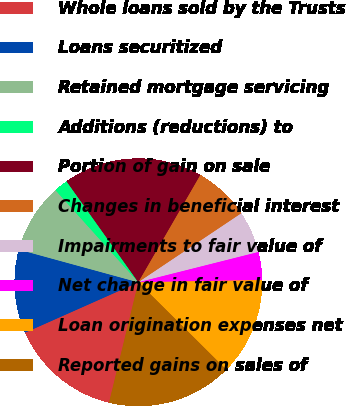Convert chart. <chart><loc_0><loc_0><loc_500><loc_500><pie_chart><fcel>Whole loans sold by the Trusts<fcel>Loans securitized<fcel>Retained mortgage servicing<fcel>Additions (reductions) to<fcel>Portion of gain on sale<fcel>Changes in beneficial interest<fcel>Impairments to fair value of<fcel>Net change in fair value of<fcel>Loan origination expenses net<fcel>Reported gains on sales of<nl><fcel>14.54%<fcel>10.91%<fcel>9.09%<fcel>1.82%<fcel>18.18%<fcel>7.27%<fcel>5.46%<fcel>3.64%<fcel>12.73%<fcel>16.36%<nl></chart> 